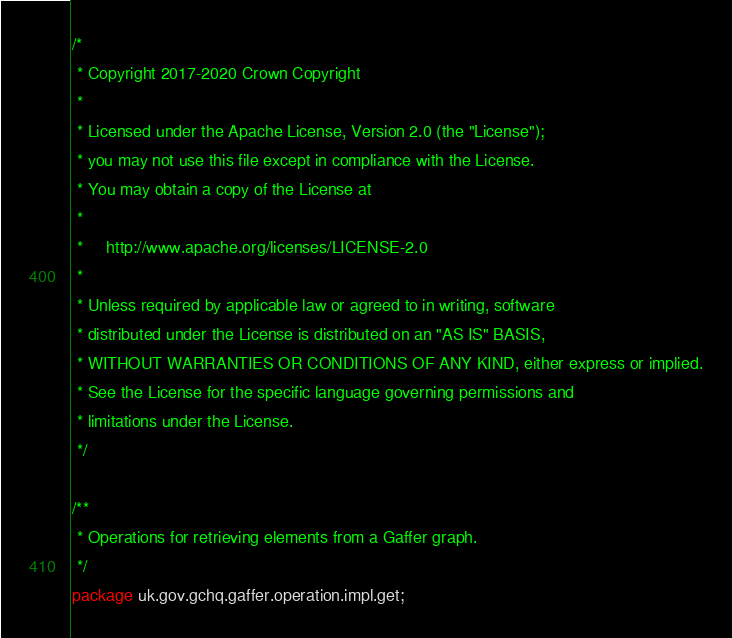Convert code to text. <code><loc_0><loc_0><loc_500><loc_500><_Java_>/*
 * Copyright 2017-2020 Crown Copyright
 *
 * Licensed under the Apache License, Version 2.0 (the "License");
 * you may not use this file except in compliance with the License.
 * You may obtain a copy of the License at
 *
 *     http://www.apache.org/licenses/LICENSE-2.0
 *
 * Unless required by applicable law or agreed to in writing, software
 * distributed under the License is distributed on an "AS IS" BASIS,
 * WITHOUT WARRANTIES OR CONDITIONS OF ANY KIND, either express or implied.
 * See the License for the specific language governing permissions and
 * limitations under the License.
 */

/**
 * Operations for retrieving elements from a Gaffer graph.
 */
package uk.gov.gchq.gaffer.operation.impl.get;
</code> 